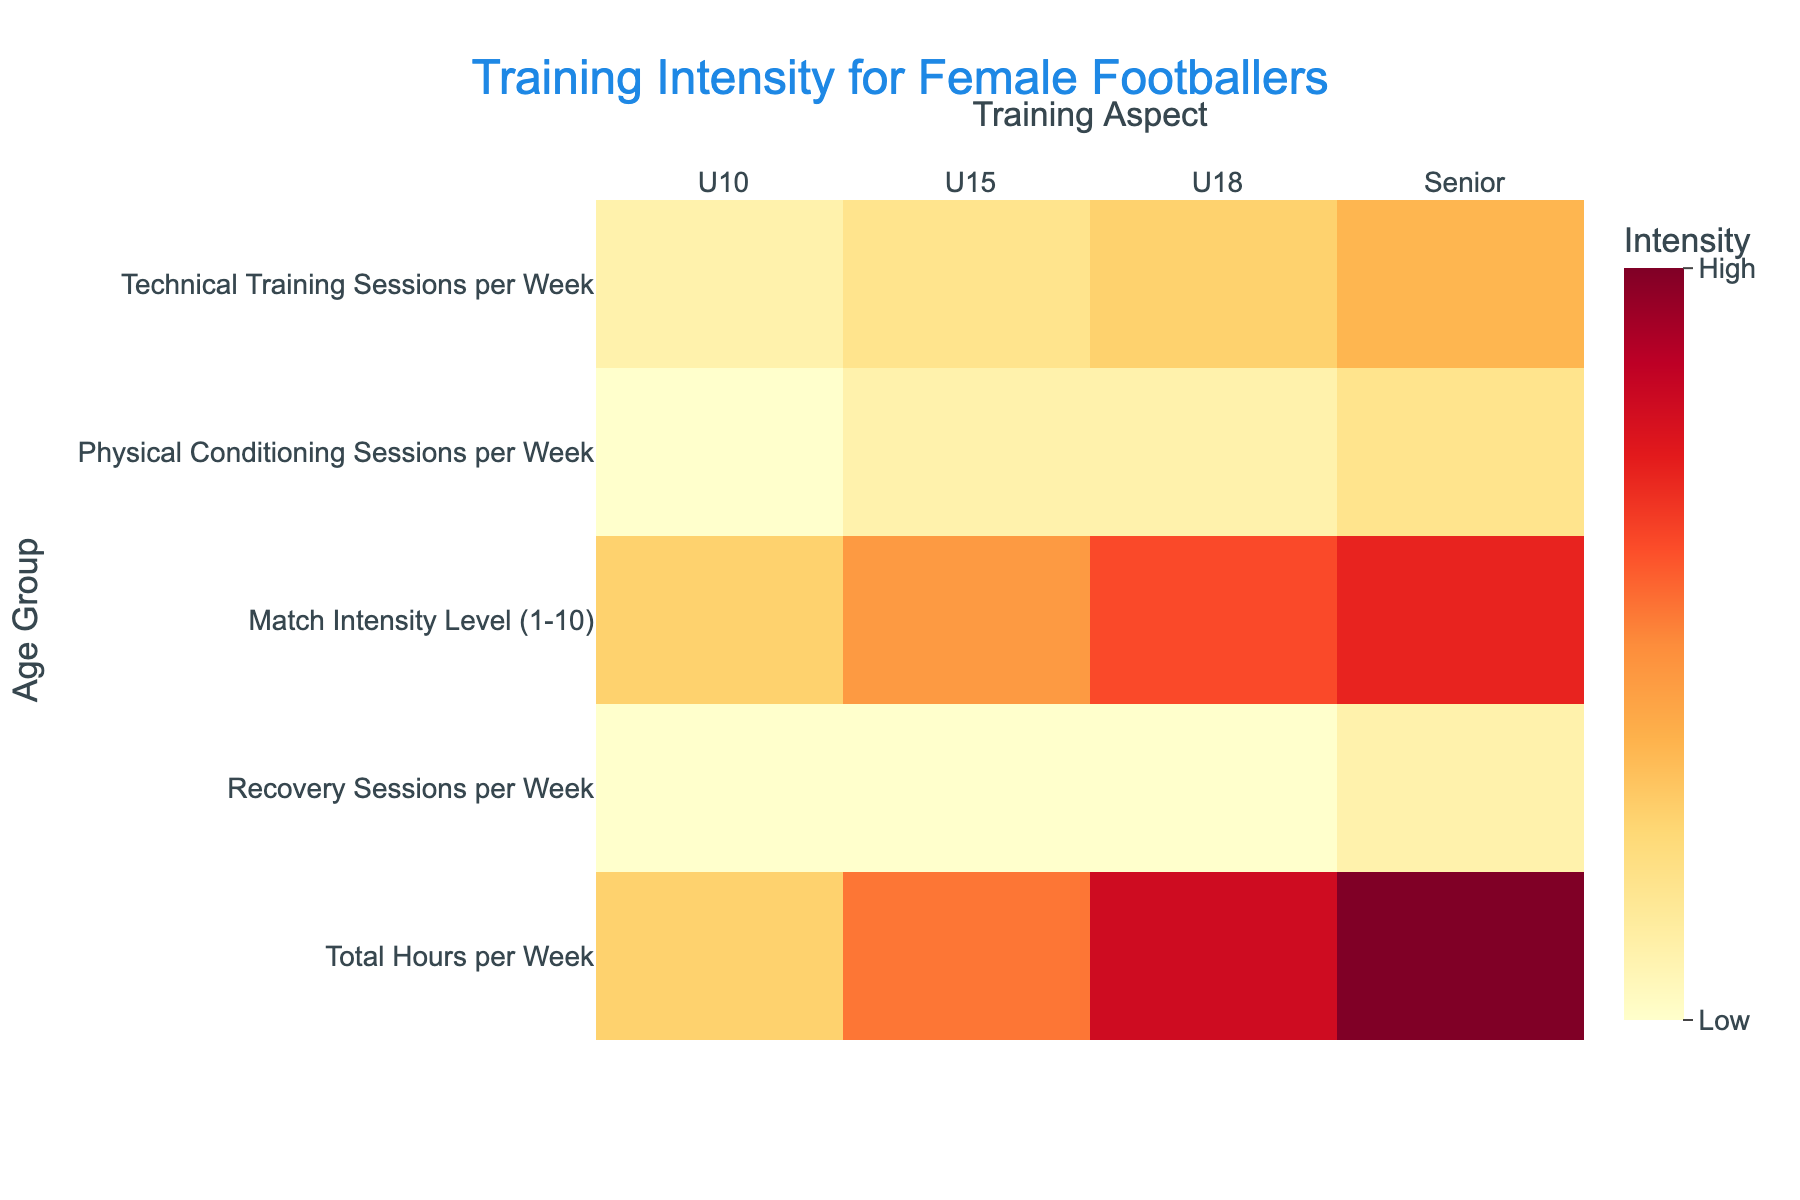What is the highest match intensity level for Senior players? The heatmap shows the match intensity level coded by color in the 1 to 10 range. Refer to the Senior row under the Match Intensity Level column to find the highest value.
Answer: 9 How many total training hours per week do U10 players have? To find the total training hours per week for U10 players, refer to the U10 row under the Total Hours per Week column.
Answer: 4 What are the different types of training sessions indicated in the heatmap? The heatmap title and x-axis labels show the types of training aspects considered in the figure. These aspects include Technical Training Sessions per Week, Physical Conditioning Sessions per Week, Match Intensity Level, Recovery Sessions per Week, and Total Hours per Week.
Answer: 5 types Which age group has the highest overall training intensity? To find the age group with the highest overall training intensity, observe the colors across all training aspects. The darkest colors in the heatmap represent the highest values for different training aspects. The Senior age group shows the darkest colors more frequently.
Answer: Senior What is the difference in the number of physical conditioning sessions per week between U10 and Senior players? To calculate the difference, refer to the Physical Conditioning Sessions per Week for U10 and Senior players. U10 has 1 session and Senior has 3 sessions; thus the difference is 3 - 1.
Answer: 2 Compare the match intensity level between U18 and U15 players. The match intensity level for U18 players is found under the U18 row and Match Intensity Level column, and for U15 players under the U15 row. U18 has a match intensity level of 8, while U15 has 6. U18 is higher.
Answer: U18 > U15 What's the average number of Technical Training Sessions per Week across all age groups? To find the average, sum up the technical training sessions per week for all age groups (2 for U10, 3 for U15, 4 for U18, and 5 for Senior). The total is 2 + 3 + 4 + 5 = 14. Divide by the number of groups: 14 / 4.
Answer: 3.5 Which age group has twice the number of recovery sessions compared to U10 players? According to the heatmap, U10 players have 1 recovery session per week. The group that has twice the number is the one with 2 recovery sessions. Check the Recovery Sessions per Week column to find which age group has 2 sessions.
Answer: Senior What is the most intense visual color represented in the heatmap and what does it indicate? Observing the color scale on the right of the heatmap, the most intense (darkest) visual color typically indicates the highest values, or "High" intensity, based on the scale from Low to High.
Answer: High Summing up, what is the total number of Training Aspects tracked per age group in the heatmap? The total number of training aspects tracked per age group can be seen by counting the distinct columns in the x-axis labels: 5 distinct training aspects are represented for each age group.
Answer: 5 